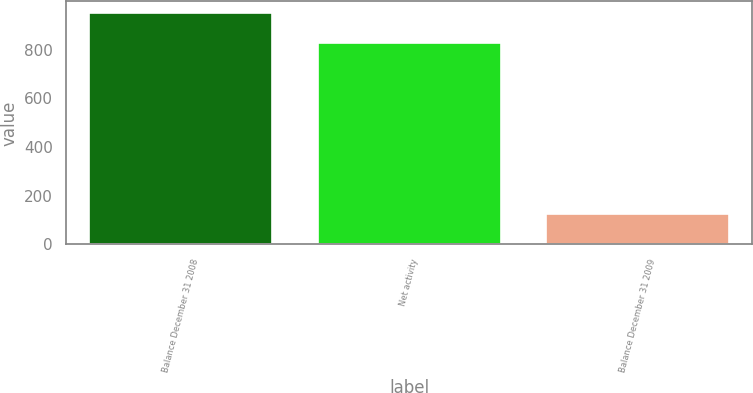Convert chart. <chart><loc_0><loc_0><loc_500><loc_500><bar_chart><fcel>Balance December 31 2008<fcel>Net activity<fcel>Balance December 31 2009<nl><fcel>952<fcel>827<fcel>125<nl></chart> 